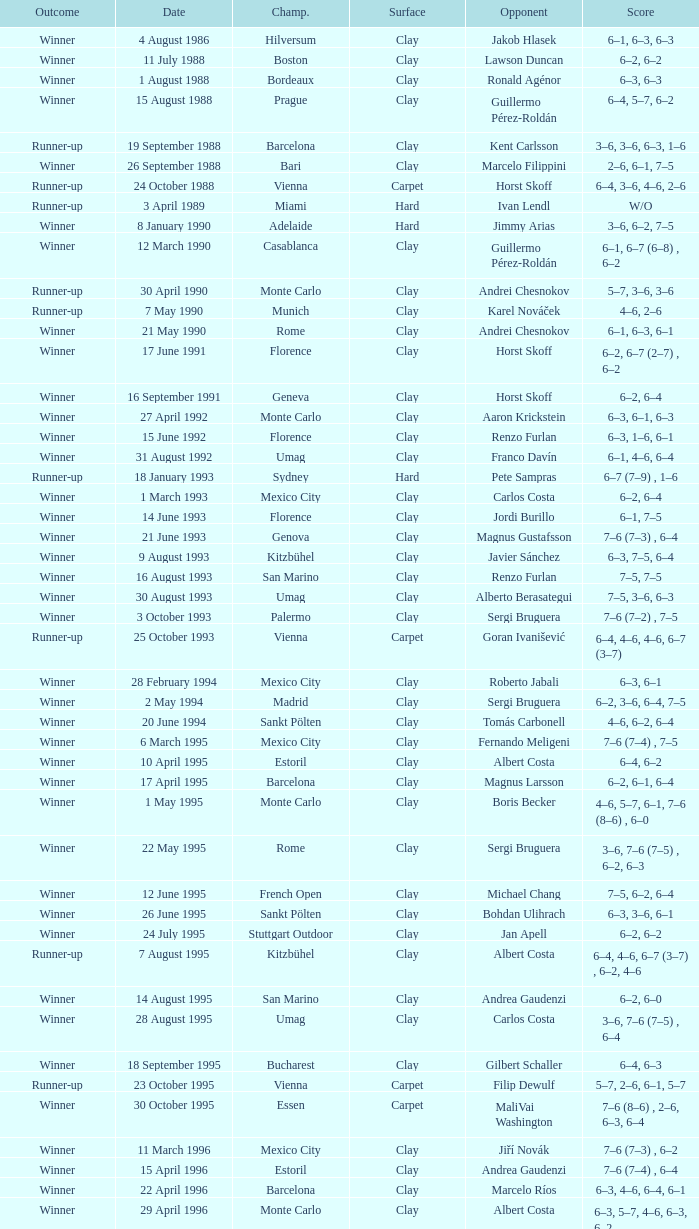What is the surface on 21 june 1993? Clay. 